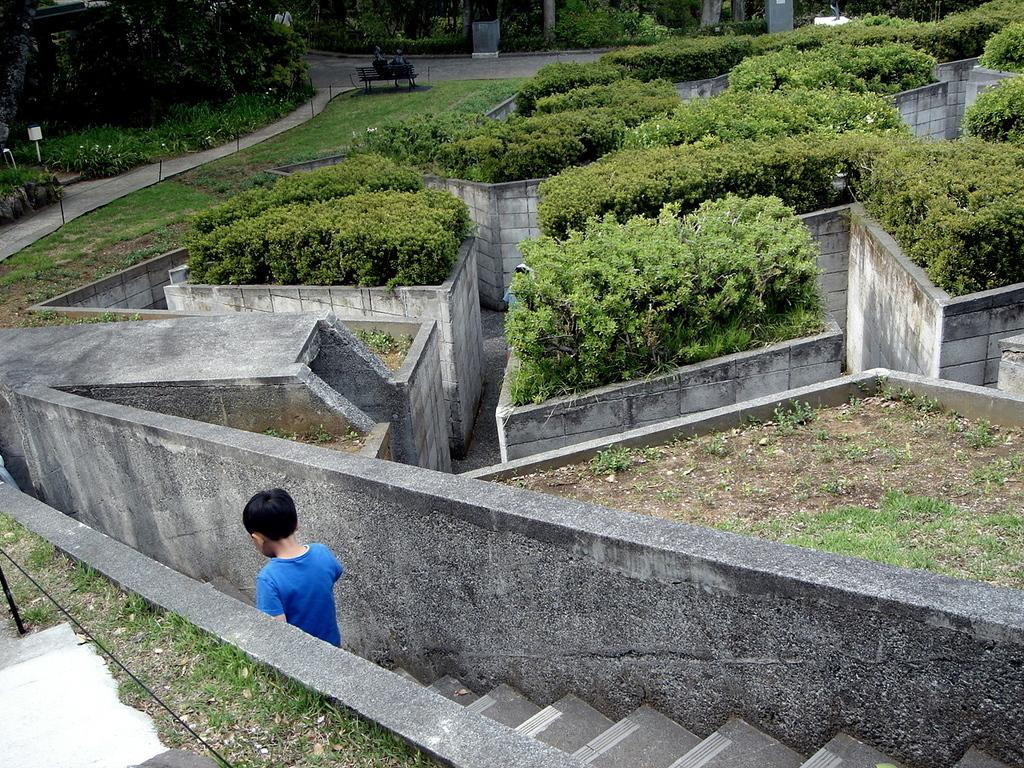What type of vegetation can be seen in the image? There are trees in the image. What type of seating is present in the image? There is a bench in the image. What is the ground covered with in the image? Grass is present on the ground. Who is in the image? There is a boy in the image. What is the boy doing in the image? The boy is getting down the stairs. What type of cough does the boy have in the image? There is no indication of a cough in the image; the boy is simply getting down the stairs. What type of plate is on the bench in the image? There is no plate present on the bench or anywhere else in the image. 